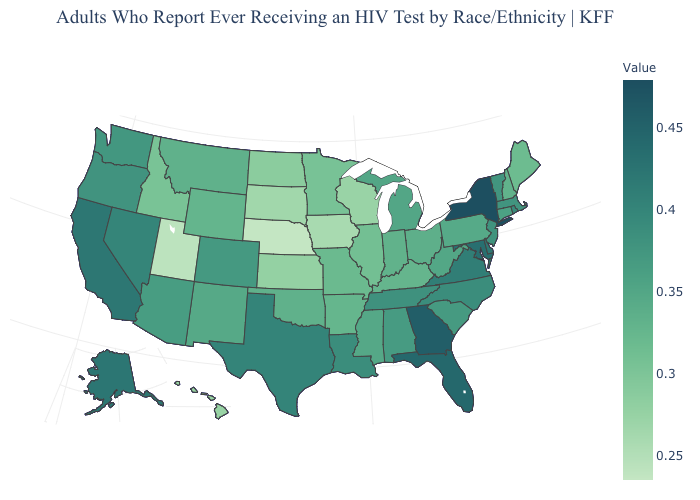Does New Mexico have a lower value than Tennessee?
Write a very short answer. Yes. Does Arkansas have a higher value than Wisconsin?
Be succinct. Yes. Among the states that border Tennessee , does Missouri have the lowest value?
Quick response, please. Yes. Among the states that border Maine , which have the highest value?
Answer briefly. New Hampshire. Which states have the highest value in the USA?
Be succinct. New York. Among the states that border New Jersey , does Pennsylvania have the highest value?
Concise answer only. No. Does New York have the highest value in the Northeast?
Answer briefly. Yes. Does Kentucky have a lower value than Hawaii?
Concise answer only. No. Does New Mexico have the lowest value in the West?
Quick response, please. No. 